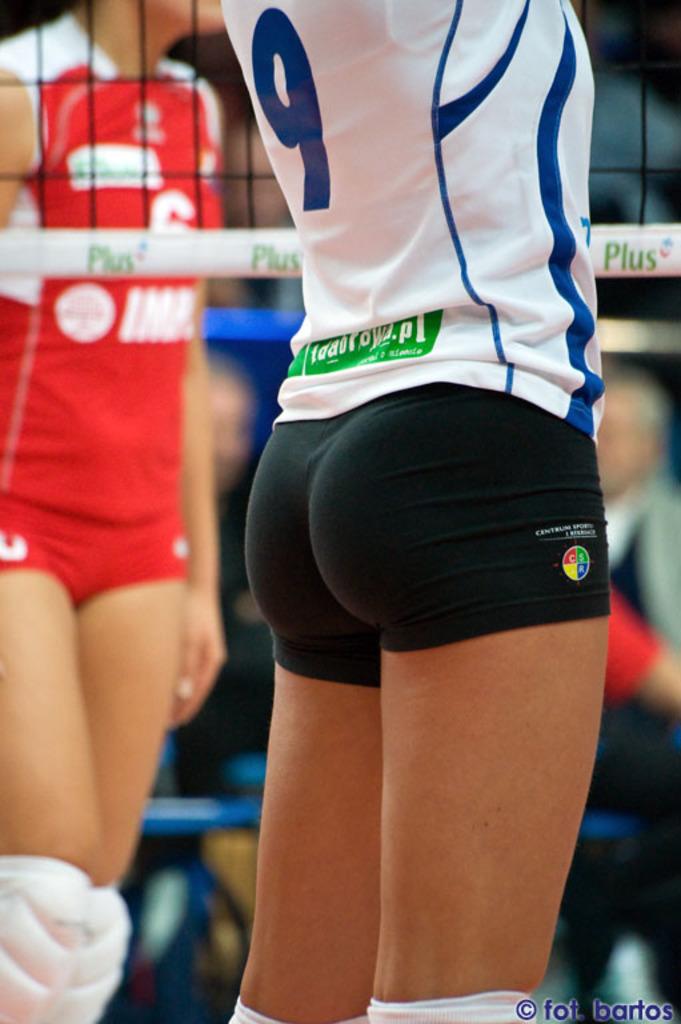Look up. what is this fantastic player's jersey number?
Provide a short and direct response. 9. What is written on the net?
Make the answer very short. Plus. 